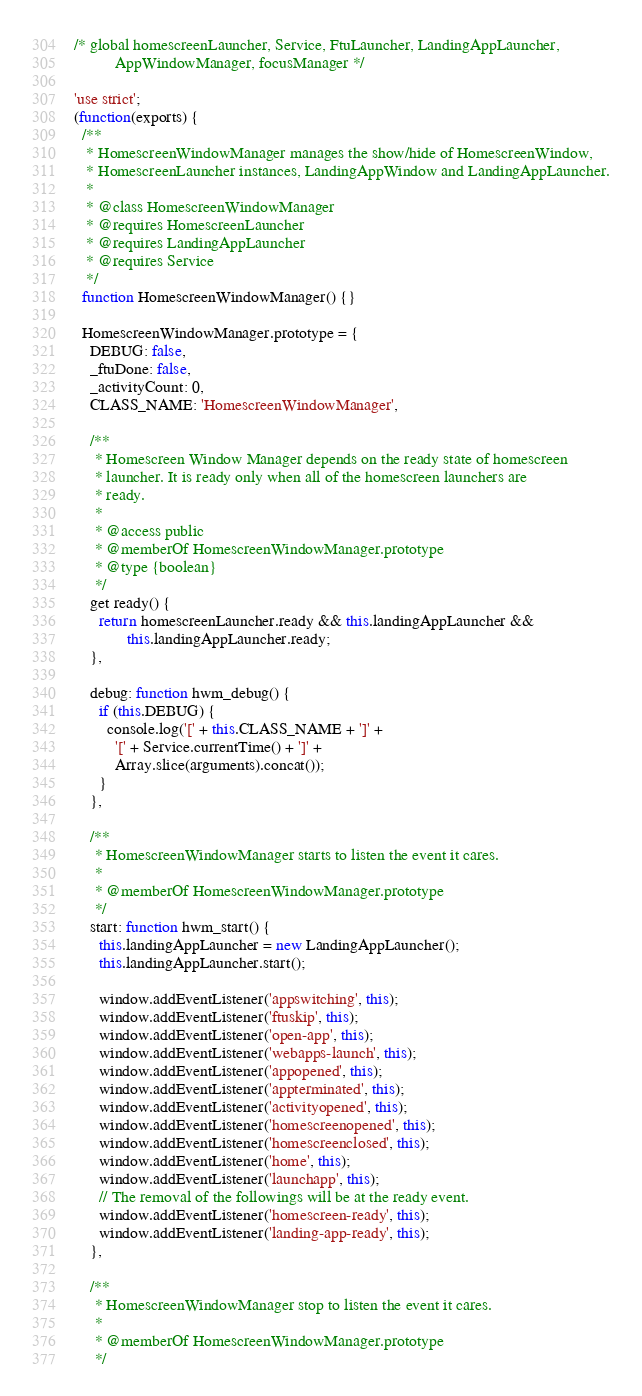Convert code to text. <code><loc_0><loc_0><loc_500><loc_500><_JavaScript_>/* global homescreenLauncher, Service, FtuLauncher, LandingAppLauncher,
          AppWindowManager, focusManager */

'use strict';
(function(exports) {
  /**
   * HomescreenWindowManager manages the show/hide of HomescreenWindow,
   * HomescreenLauncher instances, LandingAppWindow and LandingAppLauncher.
   *
   * @class HomescreenWindowManager
   * @requires HomescreenLauncher
   * @requires LandingAppLauncher
   * @requires Service
   */
  function HomescreenWindowManager() {}

  HomescreenWindowManager.prototype = {
    DEBUG: false,
    _ftuDone: false,
    _activityCount: 0,
    CLASS_NAME: 'HomescreenWindowManager',

    /**
     * Homescreen Window Manager depends on the ready state of homescreen
     * launcher. It is ready only when all of the homescreen launchers are
     * ready.
     *
     * @access public
     * @memberOf HomescreenWindowManager.prototype
     * @type {boolean}
     */
    get ready() {
      return homescreenLauncher.ready && this.landingAppLauncher &&
             this.landingAppLauncher.ready;
    },

    debug: function hwm_debug() {
      if (this.DEBUG) {
        console.log('[' + this.CLASS_NAME + ']' +
          '[' + Service.currentTime() + ']' +
          Array.slice(arguments).concat());
      }
    },

    /**
     * HomescreenWindowManager starts to listen the event it cares.
     *
     * @memberOf HomescreenWindowManager.prototype
     */
    start: function hwm_start() {
      this.landingAppLauncher = new LandingAppLauncher();
      this.landingAppLauncher.start();

      window.addEventListener('appswitching', this);
      window.addEventListener('ftuskip', this);
      window.addEventListener('open-app', this);
      window.addEventListener('webapps-launch', this);
      window.addEventListener('appopened', this);
      window.addEventListener('appterminated', this);
      window.addEventListener('activityopened', this);
      window.addEventListener('homescreenopened', this);
      window.addEventListener('homescreenclosed', this);
      window.addEventListener('home', this);
      window.addEventListener('launchapp', this);
      // The removal of the followings will be at the ready event.
      window.addEventListener('homescreen-ready', this);
      window.addEventListener('landing-app-ready', this);
    },

    /**
     * HomescreenWindowManager stop to listen the event it cares.
     *
     * @memberOf HomescreenWindowManager.prototype
     */</code> 